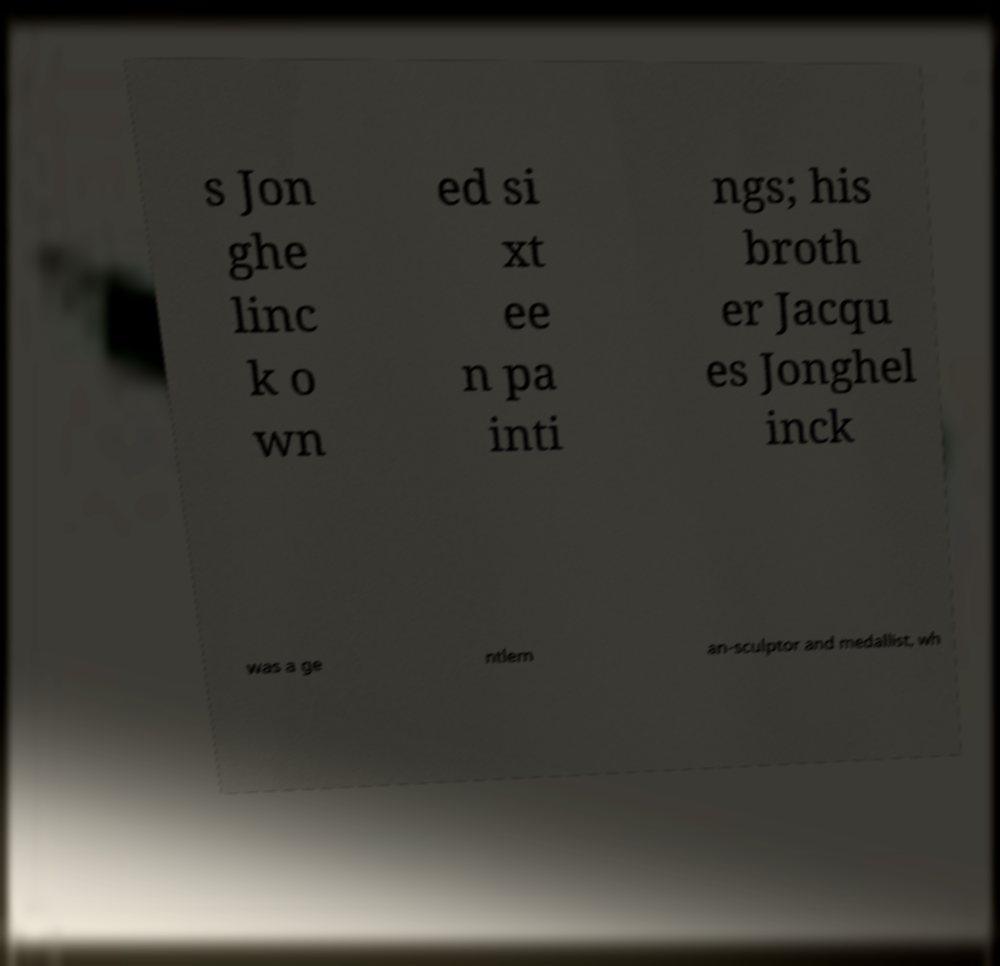For documentation purposes, I need the text within this image transcribed. Could you provide that? s Jon ghe linc k o wn ed si xt ee n pa inti ngs; his broth er Jacqu es Jonghel inck was a ge ntlem an-sculptor and medallist, wh 